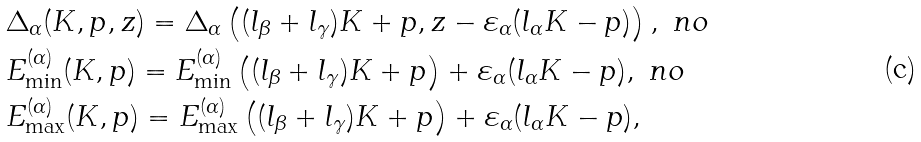Convert formula to latex. <formula><loc_0><loc_0><loc_500><loc_500>& \Delta _ { \alpha } ( K , p , z ) = \Delta _ { \alpha } \left ( ( l _ { \beta } + l _ { \gamma } ) K + p , z - \varepsilon _ { \alpha } ( l _ { \alpha } K - p ) \right ) , \ n o \\ & E ^ { ( \alpha ) } _ { \min } ( K , p ) = E ^ { ( \alpha ) } _ { \min } \left ( ( l _ { \beta } + l _ { \gamma } ) K + p \right ) + \varepsilon _ { \alpha } ( l _ { \alpha } K - p ) , \ n o \\ & E ^ { ( \alpha ) } _ { \max } ( K , p ) = E ^ { ( \alpha ) } _ { \max } \left ( ( l _ { \beta } + l _ { \gamma } ) K + p \right ) + \varepsilon _ { \alpha } ( l _ { \alpha } K - p ) ,</formula> 